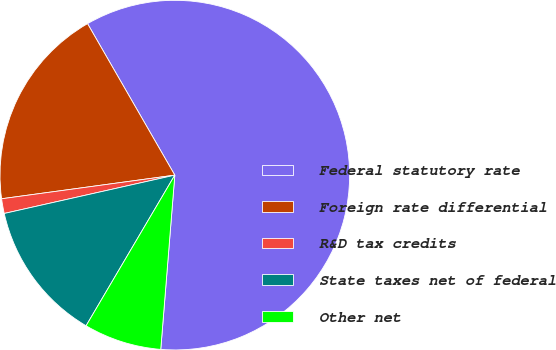<chart> <loc_0><loc_0><loc_500><loc_500><pie_chart><fcel>Federal statutory rate<fcel>Foreign rate differential<fcel>R&D tax credits<fcel>State taxes net of federal<fcel>Other net<nl><fcel>59.6%<fcel>18.84%<fcel>1.36%<fcel>13.01%<fcel>7.19%<nl></chart> 